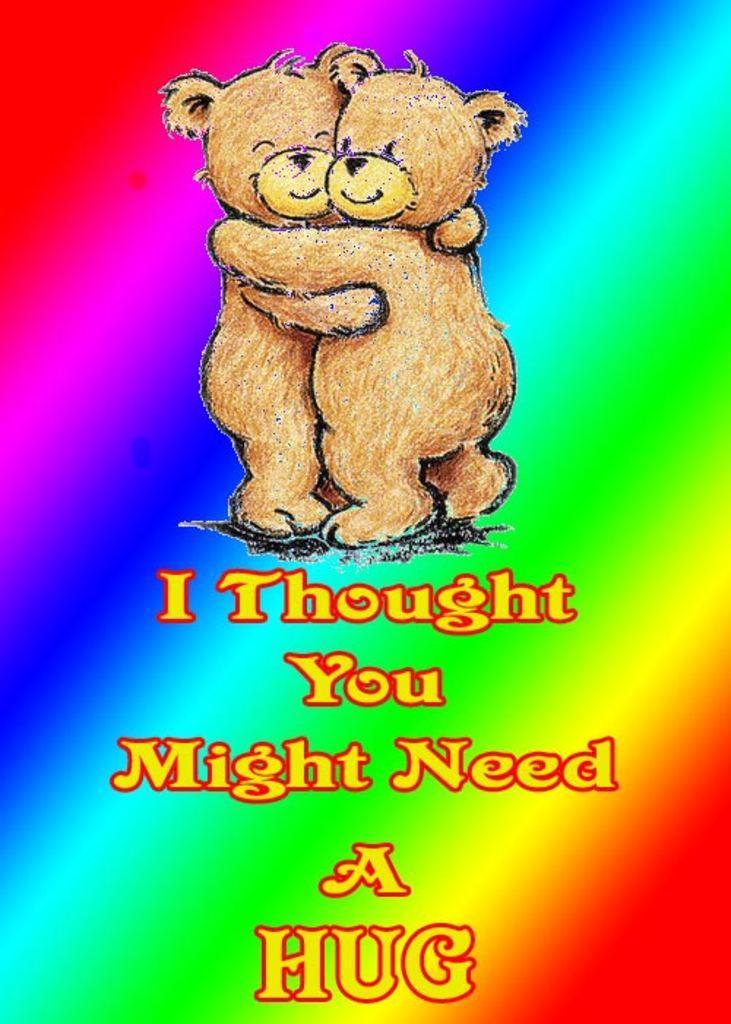Can you describe this image briefly? This is an animated image in which there is some text and there are teddy bears. 